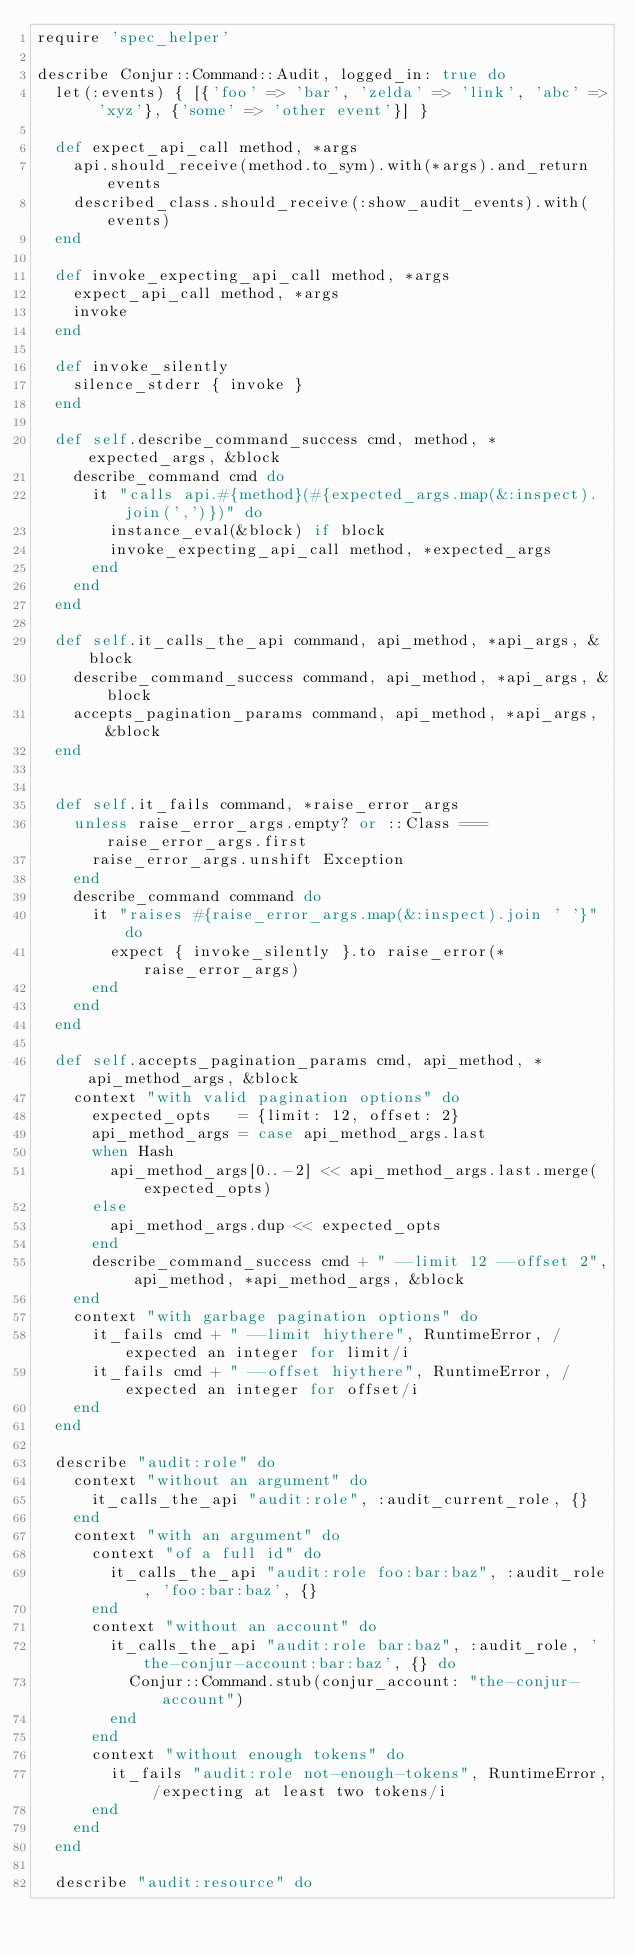<code> <loc_0><loc_0><loc_500><loc_500><_Ruby_>require 'spec_helper'

describe Conjur::Command::Audit, logged_in: true do
  let(:events) { [{'foo' => 'bar', 'zelda' => 'link', 'abc' => 'xyz'}, {'some' => 'other event'}] }

  def expect_api_call method, *args
    api.should_receive(method.to_sym).with(*args).and_return events
    described_class.should_receive(:show_audit_events).with(events)
  end

  def invoke_expecting_api_call method, *args
    expect_api_call method, *args
    invoke
  end

  def invoke_silently
    silence_stderr { invoke }
  end

  def self.describe_command_success cmd, method, *expected_args, &block
    describe_command cmd do
      it "calls api.#{method}(#{expected_args.map(&:inspect).join(',')})" do
        instance_eval(&block) if block
        invoke_expecting_api_call method, *expected_args
      end
    end
  end

  def self.it_calls_the_api command, api_method, *api_args, &block
    describe_command_success command, api_method, *api_args, &block
    accepts_pagination_params command, api_method, *api_args, &block
  end


  def self.it_fails command, *raise_error_args
    unless raise_error_args.empty? or ::Class === raise_error_args.first
      raise_error_args.unshift Exception
    end
    describe_command command do
      it "raises #{raise_error_args.map(&:inspect).join ' '}" do
        expect { invoke_silently }.to raise_error(*raise_error_args)
      end
    end
  end

  def self.accepts_pagination_params cmd, api_method, *api_method_args, &block
    context "with valid pagination options" do
      expected_opts   = {limit: 12, offset: 2}
      api_method_args = case api_method_args.last
      when Hash
        api_method_args[0..-2] << api_method_args.last.merge(expected_opts)
      else
        api_method_args.dup << expected_opts
      end
      describe_command_success cmd + " --limit 12 --offset 2", api_method, *api_method_args, &block
    end
    context "with garbage pagination options" do
      it_fails cmd + " --limit hiythere", RuntimeError, /expected an integer for limit/i
      it_fails cmd + " --offset hiythere", RuntimeError, /expected an integer for offset/i
    end
  end

  describe "audit:role" do
    context "without an argument" do
      it_calls_the_api "audit:role", :audit_current_role, {}
    end
    context "with an argument" do
      context "of a full id" do
        it_calls_the_api "audit:role foo:bar:baz", :audit_role, 'foo:bar:baz', {}
      end
      context "without an account" do
        it_calls_the_api "audit:role bar:baz", :audit_role, 'the-conjur-account:bar:baz', {} do
          Conjur::Command.stub(conjur_account: "the-conjur-account")
        end
      end
      context "without enough tokens" do
        it_fails "audit:role not-enough-tokens", RuntimeError, /expecting at least two tokens/i
      end
    end
  end

  describe "audit:resource" do</code> 